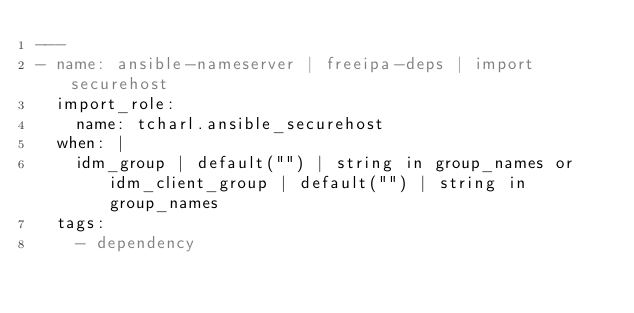<code> <loc_0><loc_0><loc_500><loc_500><_YAML_>---
- name: ansible-nameserver | freeipa-deps | import securehost
  import_role:
    name: tcharl.ansible_securehost
  when: |
    idm_group | default("") | string in group_names or idm_client_group | default("") | string in group_names
  tags:
    - dependency
</code> 